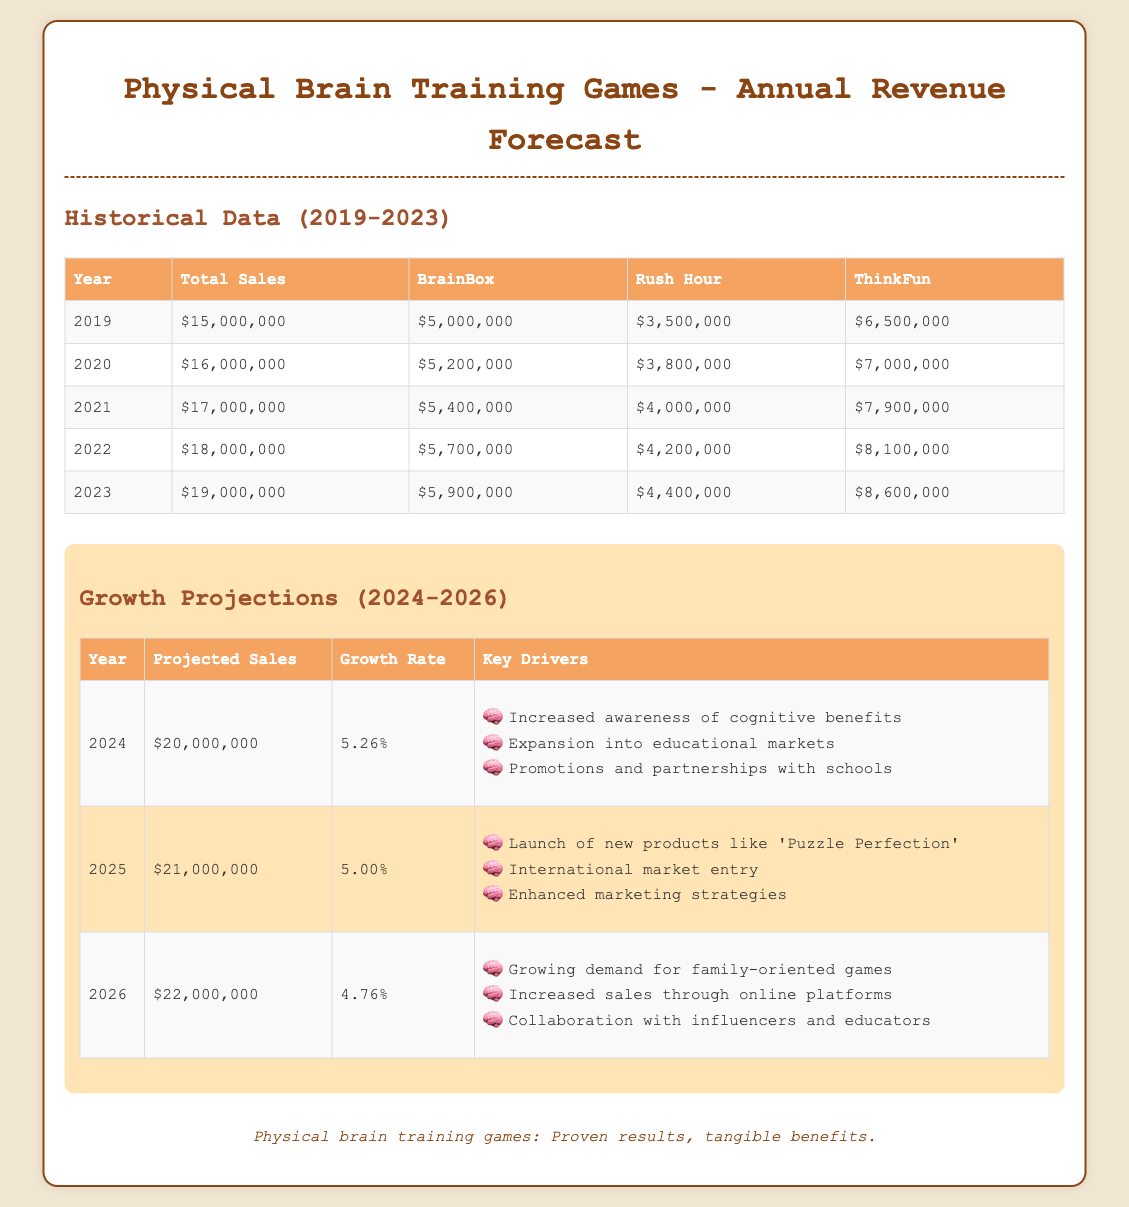what was the total sales in 2020? The total sales for 2020 is specifically noted in the historical data table, which shows $16,000,000.
Answer: $16,000,000 what are the projected sales for 2025? The projected sales for 2025 is given in the growth projections table as $21,000,000.
Answer: $21,000,000 which game had the highest sales in 2022? By examining the historical data for 2022, ThinkFun has the highest sales amount of $8,100,000.
Answer: ThinkFun what is the growth rate for 2024? The growth rate for 2024 can be found in the growth projections table which states 5.26%.
Answer: 5.26% how many years are shown in the historical data? The historical data spans from 2019 to 2023, totaling five years of data displayed.
Answer: 5 years what is one key driver for growth in 2026? The document lists several key drivers for 2026, one of which is "Growing demand for family-oriented games".
Answer: Growing demand for family-oriented games what was the total sales in 2019? The total sales noted for 2019 in the historical data table is $15,000,000.
Answer: $15,000,000 which year shows the highest total sales growth in percentage? Comparing the historical data from 2019 to 2023, the growth from 2019 to 2023 is the highest, which is approximately 26.67%.
Answer: 26.67% 